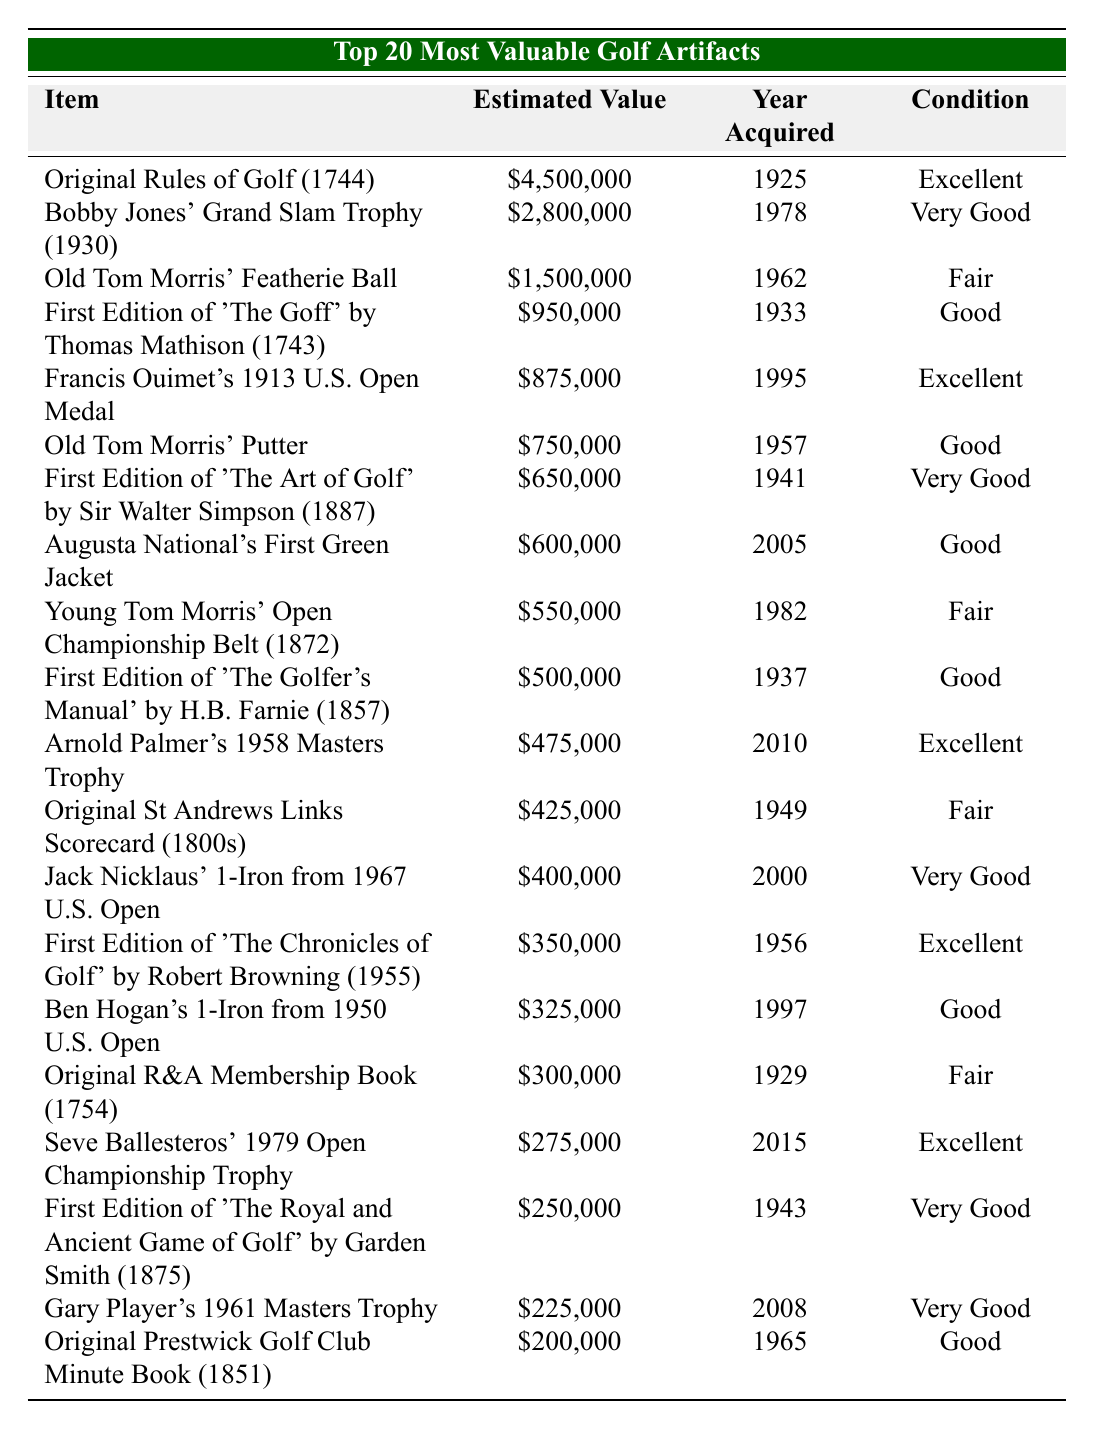What is the estimated value of Bobby Jones' Grand Slam Trophy? The table lists Bobby Jones' Grand Slam Trophy with an estimated value of $2,800,000.
Answer: $2,800,000 Which item has the highest estimated value? The item with the highest estimated value in the table is the Original Rules of Golf (1744), valued at $4,500,000.
Answer: Original Rules of Golf (1744) How many artifacts were acquired in the 2000s? From the table, the artifacts acquired in the 2000s are Arnold Palmer's 1958 Masters Trophy (2010), Jack Nicklaus' 1-Iron from 1967 U.S. Open (2000), Seve Ballesteros' 1979 Open Championship Trophy (2015), Augusta National's First Green Jacket (2005), and Gary Player's 1961 Masters Trophy (2008). There are 5 artifacts.
Answer: 5 What is the condition of the Old Tom Morris’ Featherie Ball? The table states that Old Tom Morris’ Featherie Ball is in Fair condition.
Answer: Fair What is the median estimated value of all artifacts listed? To find the median value, we first list the values: $4,500,000, $2,800,000, $1,500,000, $950,000, $875,000, $750,000, $650,000, $600,000, $550,000, $500,000, $475,000, $425,000, $400,000, $350,000, $325,000, $300,000, $275,000, $250,000, $225,000, $200,000. There are 20 items. The median is the average of the 10th and 11th values: ($500,000 + $475,000)/2 = $487,500.
Answer: $487,500 Which item was acquired in 1995 and what is its estimated value? The table indicates that the Francis Ouimet's 1913 U.S. Open Medal was acquired in 1995, and its estimated value is $875,000.
Answer: $875,000 How many artifacts are in Excellent condition? By reviewing the table, the items in Excellent condition are the Original Rules of Golf (1744), Francis Ouimet's 1913 U.S. Open Medal, Arnold Palmer's 1958 Masters Trophy, First Edition of 'The Chronicles of Golf' by Robert Browning (1955), and Seve Ballesteros' 1979 Open Championship Trophy, totaling 5 artifacts.
Answer: 5 Did any items acquired before 1950 have an estimated value over $1 million? Yes, the Original Rules of Golf (1744) and Old Tom Morris' Featherie Ball both have estimated values over $1 million and were acquired before 1950 (1925 and 1962, respectively).
Answer: Yes What was the estimated value of the First Edition of 'The Art of Golf' by Sir Walter Simpson? The estimated value of the First Edition of 'The Art of Golf' by Sir Walter Simpson is $650,000, as indicated in the table.
Answer: $650,000 Which item in Fair condition has the lowest estimated value? The item in Fair condition with the lowest estimated value is the Original R&A Membership Book (1754), valued at $300,000.
Answer: Original R&A Membership Book (1754) What is the difference in estimated value between Bobby Jones' Grand Slam Trophy and Old Tom Morris' Putter? The estimated value of Bobby Jones' Grand Slam Trophy is $2,800,000, and Old Tom Morris' Putter is $750,000. The difference is $2,800,000 - $750,000 = $2,050,000.
Answer: $2,050,000 